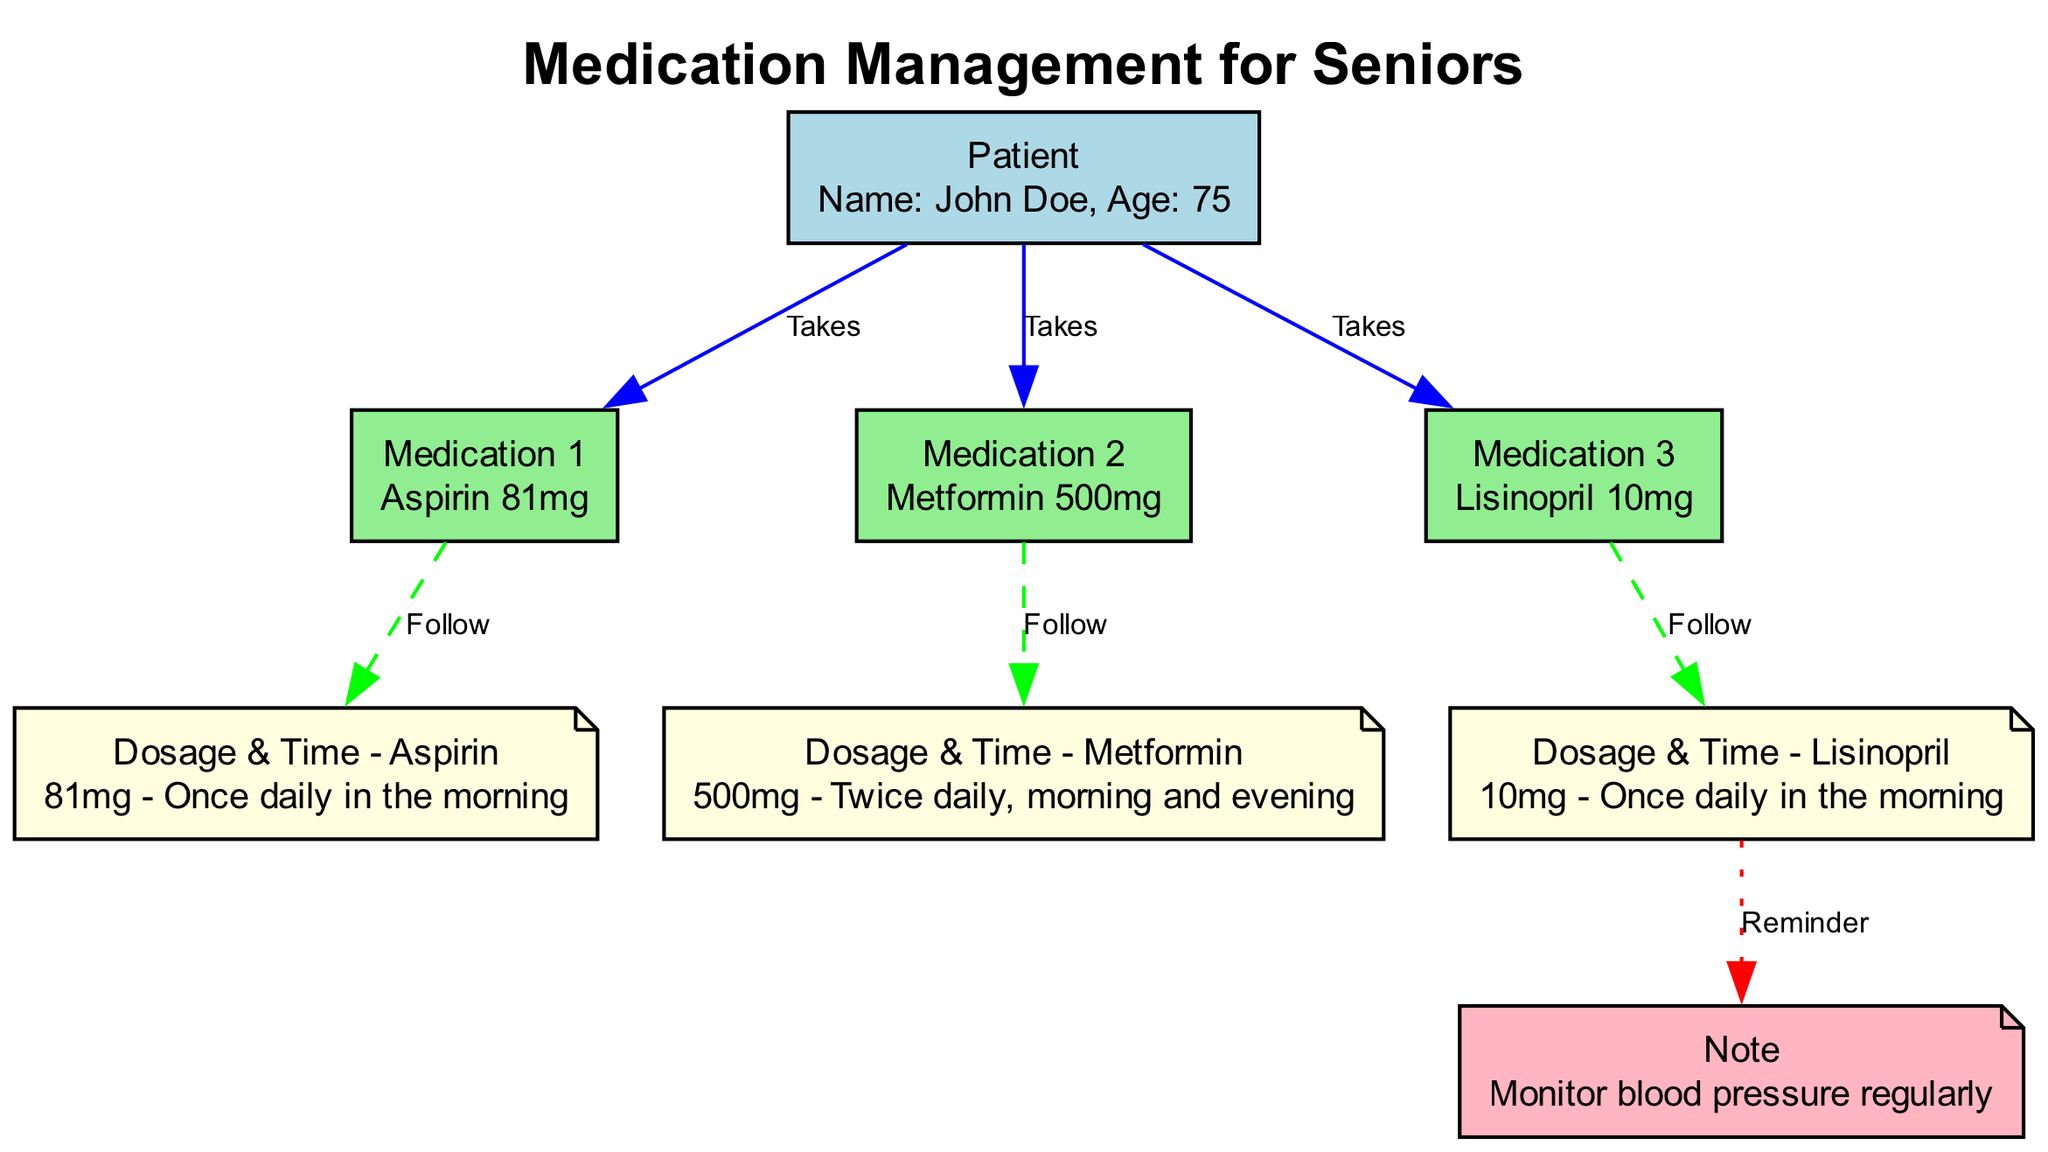What is the name of the patient? The diagram labels the patient node as "Patient" and provides the details below which state "Name: John Doe". Therefore, the patient's name is directly stated in the diagram.
Answer: John Doe How many medications is John Doe taking? The diagram shows three edges leading from the patient node labeled "Takes" which connect to the three medication nodes. Each edge represents a medication being taken by the patient, indicating there are three medications.
Answer: Three What is the dosage and frequency of Metformin? For Metformin, we can find the medication node "Medication 2" that leads to the dosage node "Dosage & Time - Metformin". The dosage node indicates "500mg - Twice daily, morning and evening", thus directly answering the question about dosage and frequency.
Answer: 500mg - Twice daily, morning and evening Which medication requires monitoring of blood pressure? The diagram has a note connected to the Lisinopril dosage node. The note states "Monitor blood pressure regularly", which means that this medication requires monitoring of blood pressure. Thus, we can identify Lisinopril as responsible for this requirement.
Answer: Lisinopril What color is the dosage information for Aspirin? In the diagram, the dosage node for Aspirin is depicted with the label "Dosage & Time - Aspirin". This node is filled with light yellow color, which is indicative of dosage information. Therefore, we can straightforwardly conclude the color associated with Aspirin's dosage.
Answer: Light yellow What type of relationship exists between Lisinopril and the monitoring note? The edge labeled "Reminder" connects Lisinopril to the note about monitoring blood pressure. This specific labeling indicates a relationship where there is an emphasis on a reminder regarding the dosage's monitoring requirement, distinguishing it from other types of connections in the diagram.
Answer: Reminder How often should Lisinopril be taken? Looking at the Lisinopril node and its directed connection to the "Dosage & Time - Lisinopril" node, we can extract that the dosage instruction states "10mg - Once daily in the morning". This clearly defines how often Lisinopril should be taken.
Answer: Once daily in the morning What type of diagram is displayed? The overall structure and content indicate that this is a Biomedical Diagram specifically focused on medication management for a senior patient. It features nodes representing the patient, medications, dosages, and instructions, all arranged in a way that communicates medication schedules.
Answer: Biomedical Diagram 